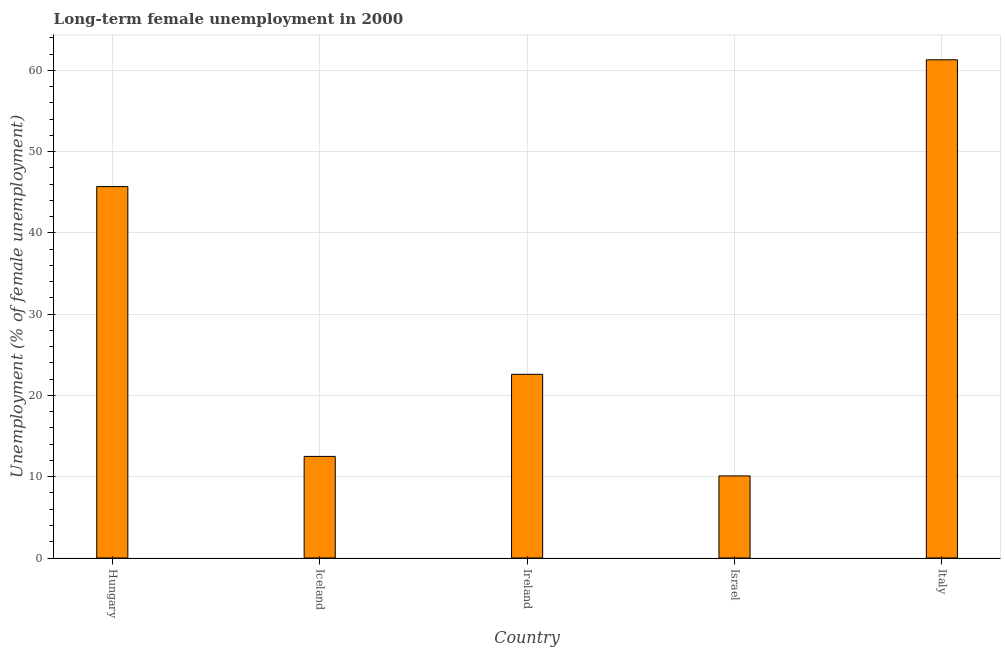Does the graph contain any zero values?
Give a very brief answer. No. What is the title of the graph?
Offer a terse response. Long-term female unemployment in 2000. What is the label or title of the Y-axis?
Offer a terse response. Unemployment (% of female unemployment). What is the long-term female unemployment in Ireland?
Keep it short and to the point. 22.6. Across all countries, what is the maximum long-term female unemployment?
Ensure brevity in your answer.  61.3. Across all countries, what is the minimum long-term female unemployment?
Offer a terse response. 10.1. What is the sum of the long-term female unemployment?
Make the answer very short. 152.2. What is the difference between the long-term female unemployment in Israel and Italy?
Your answer should be compact. -51.2. What is the average long-term female unemployment per country?
Ensure brevity in your answer.  30.44. What is the median long-term female unemployment?
Give a very brief answer. 22.6. In how many countries, is the long-term female unemployment greater than 16 %?
Give a very brief answer. 3. What is the ratio of the long-term female unemployment in Iceland to that in Italy?
Your answer should be compact. 0.2. Is the difference between the long-term female unemployment in Iceland and Israel greater than the difference between any two countries?
Ensure brevity in your answer.  No. What is the difference between the highest and the second highest long-term female unemployment?
Your answer should be compact. 15.6. What is the difference between the highest and the lowest long-term female unemployment?
Your response must be concise. 51.2. In how many countries, is the long-term female unemployment greater than the average long-term female unemployment taken over all countries?
Offer a very short reply. 2. How many bars are there?
Keep it short and to the point. 5. Are all the bars in the graph horizontal?
Your answer should be compact. No. What is the difference between two consecutive major ticks on the Y-axis?
Provide a succinct answer. 10. Are the values on the major ticks of Y-axis written in scientific E-notation?
Keep it short and to the point. No. What is the Unemployment (% of female unemployment) of Hungary?
Make the answer very short. 45.7. What is the Unemployment (% of female unemployment) in Iceland?
Ensure brevity in your answer.  12.5. What is the Unemployment (% of female unemployment) in Ireland?
Offer a very short reply. 22.6. What is the Unemployment (% of female unemployment) in Israel?
Keep it short and to the point. 10.1. What is the Unemployment (% of female unemployment) in Italy?
Your answer should be very brief. 61.3. What is the difference between the Unemployment (% of female unemployment) in Hungary and Iceland?
Your response must be concise. 33.2. What is the difference between the Unemployment (% of female unemployment) in Hungary and Ireland?
Your response must be concise. 23.1. What is the difference between the Unemployment (% of female unemployment) in Hungary and Israel?
Provide a short and direct response. 35.6. What is the difference between the Unemployment (% of female unemployment) in Hungary and Italy?
Make the answer very short. -15.6. What is the difference between the Unemployment (% of female unemployment) in Iceland and Ireland?
Your answer should be compact. -10.1. What is the difference between the Unemployment (% of female unemployment) in Iceland and Israel?
Provide a short and direct response. 2.4. What is the difference between the Unemployment (% of female unemployment) in Iceland and Italy?
Ensure brevity in your answer.  -48.8. What is the difference between the Unemployment (% of female unemployment) in Ireland and Italy?
Your response must be concise. -38.7. What is the difference between the Unemployment (% of female unemployment) in Israel and Italy?
Provide a succinct answer. -51.2. What is the ratio of the Unemployment (% of female unemployment) in Hungary to that in Iceland?
Give a very brief answer. 3.66. What is the ratio of the Unemployment (% of female unemployment) in Hungary to that in Ireland?
Your answer should be very brief. 2.02. What is the ratio of the Unemployment (% of female unemployment) in Hungary to that in Israel?
Provide a succinct answer. 4.53. What is the ratio of the Unemployment (% of female unemployment) in Hungary to that in Italy?
Offer a very short reply. 0.75. What is the ratio of the Unemployment (% of female unemployment) in Iceland to that in Ireland?
Make the answer very short. 0.55. What is the ratio of the Unemployment (% of female unemployment) in Iceland to that in Israel?
Offer a very short reply. 1.24. What is the ratio of the Unemployment (% of female unemployment) in Iceland to that in Italy?
Ensure brevity in your answer.  0.2. What is the ratio of the Unemployment (% of female unemployment) in Ireland to that in Israel?
Your answer should be compact. 2.24. What is the ratio of the Unemployment (% of female unemployment) in Ireland to that in Italy?
Keep it short and to the point. 0.37. What is the ratio of the Unemployment (% of female unemployment) in Israel to that in Italy?
Provide a succinct answer. 0.17. 